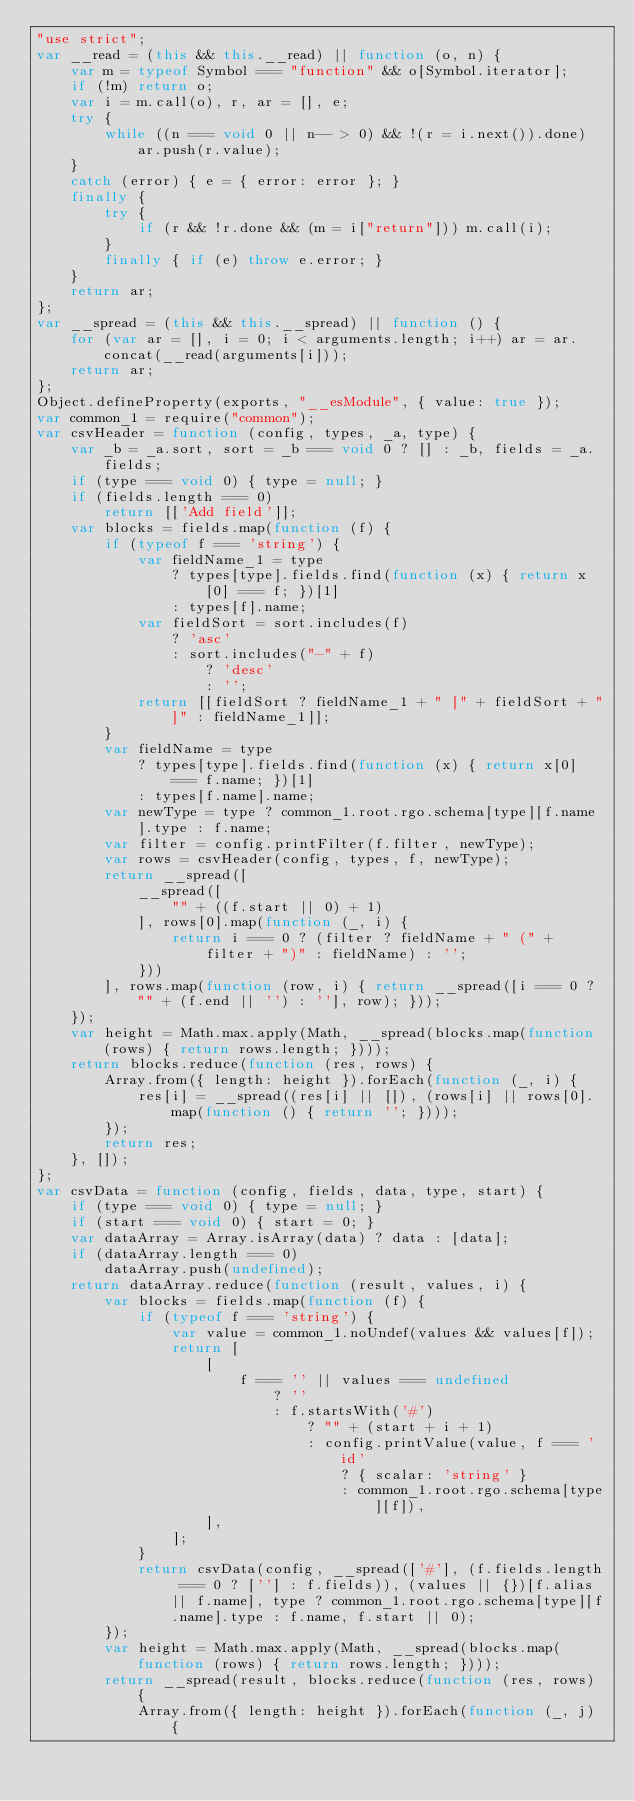<code> <loc_0><loc_0><loc_500><loc_500><_JavaScript_>"use strict";
var __read = (this && this.__read) || function (o, n) {
    var m = typeof Symbol === "function" && o[Symbol.iterator];
    if (!m) return o;
    var i = m.call(o), r, ar = [], e;
    try {
        while ((n === void 0 || n-- > 0) && !(r = i.next()).done) ar.push(r.value);
    }
    catch (error) { e = { error: error }; }
    finally {
        try {
            if (r && !r.done && (m = i["return"])) m.call(i);
        }
        finally { if (e) throw e.error; }
    }
    return ar;
};
var __spread = (this && this.__spread) || function () {
    for (var ar = [], i = 0; i < arguments.length; i++) ar = ar.concat(__read(arguments[i]));
    return ar;
};
Object.defineProperty(exports, "__esModule", { value: true });
var common_1 = require("common");
var csvHeader = function (config, types, _a, type) {
    var _b = _a.sort, sort = _b === void 0 ? [] : _b, fields = _a.fields;
    if (type === void 0) { type = null; }
    if (fields.length === 0)
        return [['Add field']];
    var blocks = fields.map(function (f) {
        if (typeof f === 'string') {
            var fieldName_1 = type
                ? types[type].fields.find(function (x) { return x[0] === f; })[1]
                : types[f].name;
            var fieldSort = sort.includes(f)
                ? 'asc'
                : sort.includes("-" + f)
                    ? 'desc'
                    : '';
            return [[fieldSort ? fieldName_1 + " [" + fieldSort + "]" : fieldName_1]];
        }
        var fieldName = type
            ? types[type].fields.find(function (x) { return x[0] === f.name; })[1]
            : types[f.name].name;
        var newType = type ? common_1.root.rgo.schema[type][f.name].type : f.name;
        var filter = config.printFilter(f.filter, newType);
        var rows = csvHeader(config, types, f, newType);
        return __spread([
            __spread([
                "" + ((f.start || 0) + 1)
            ], rows[0].map(function (_, i) {
                return i === 0 ? (filter ? fieldName + " (" + filter + ")" : fieldName) : '';
            }))
        ], rows.map(function (row, i) { return __spread([i === 0 ? "" + (f.end || '') : ''], row); }));
    });
    var height = Math.max.apply(Math, __spread(blocks.map(function (rows) { return rows.length; })));
    return blocks.reduce(function (res, rows) {
        Array.from({ length: height }).forEach(function (_, i) {
            res[i] = __spread((res[i] || []), (rows[i] || rows[0].map(function () { return ''; })));
        });
        return res;
    }, []);
};
var csvData = function (config, fields, data, type, start) {
    if (type === void 0) { type = null; }
    if (start === void 0) { start = 0; }
    var dataArray = Array.isArray(data) ? data : [data];
    if (dataArray.length === 0)
        dataArray.push(undefined);
    return dataArray.reduce(function (result, values, i) {
        var blocks = fields.map(function (f) {
            if (typeof f === 'string') {
                var value = common_1.noUndef(values && values[f]);
                return [
                    [
                        f === '' || values === undefined
                            ? ''
                            : f.startsWith('#')
                                ? "" + (start + i + 1)
                                : config.printValue(value, f === 'id'
                                    ? { scalar: 'string' }
                                    : common_1.root.rgo.schema[type][f]),
                    ],
                ];
            }
            return csvData(config, __spread(['#'], (f.fields.length === 0 ? [''] : f.fields)), (values || {})[f.alias || f.name], type ? common_1.root.rgo.schema[type][f.name].type : f.name, f.start || 0);
        });
        var height = Math.max.apply(Math, __spread(blocks.map(function (rows) { return rows.length; })));
        return __spread(result, blocks.reduce(function (res, rows) {
            Array.from({ length: height }).forEach(function (_, j) {</code> 